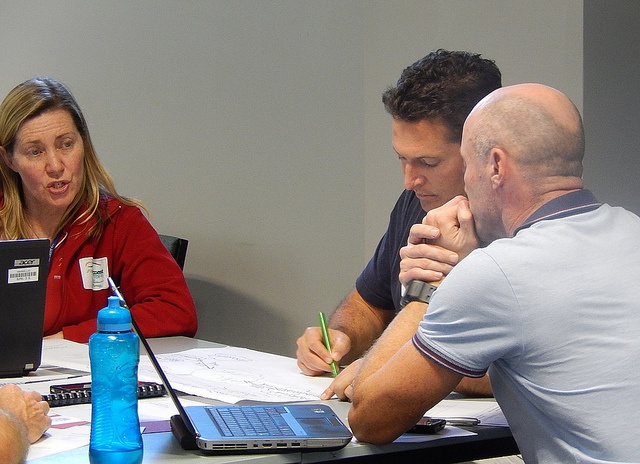Describe the objects in this image and their specific colors. I can see people in darkgray, lightgray, gray, and tan tones, people in darkgray, maroon, brown, and black tones, people in darkgray, black, brown, gray, and tan tones, bottle in darkgray, lightblue, teal, and gray tones, and laptop in darkgray, lightblue, and gray tones in this image. 